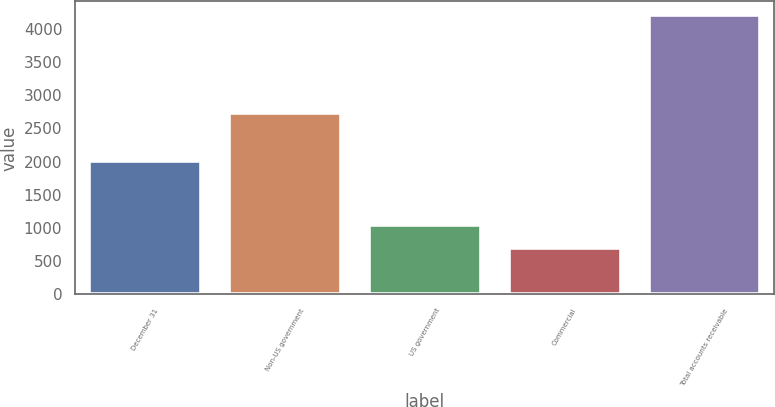Convert chart to OTSL. <chart><loc_0><loc_0><loc_500><loc_500><bar_chart><fcel>December 31<fcel>Non-US government<fcel>US government<fcel>Commercial<fcel>Total accounts receivable<nl><fcel>2012<fcel>2728<fcel>1048.6<fcel>698<fcel>4204<nl></chart> 